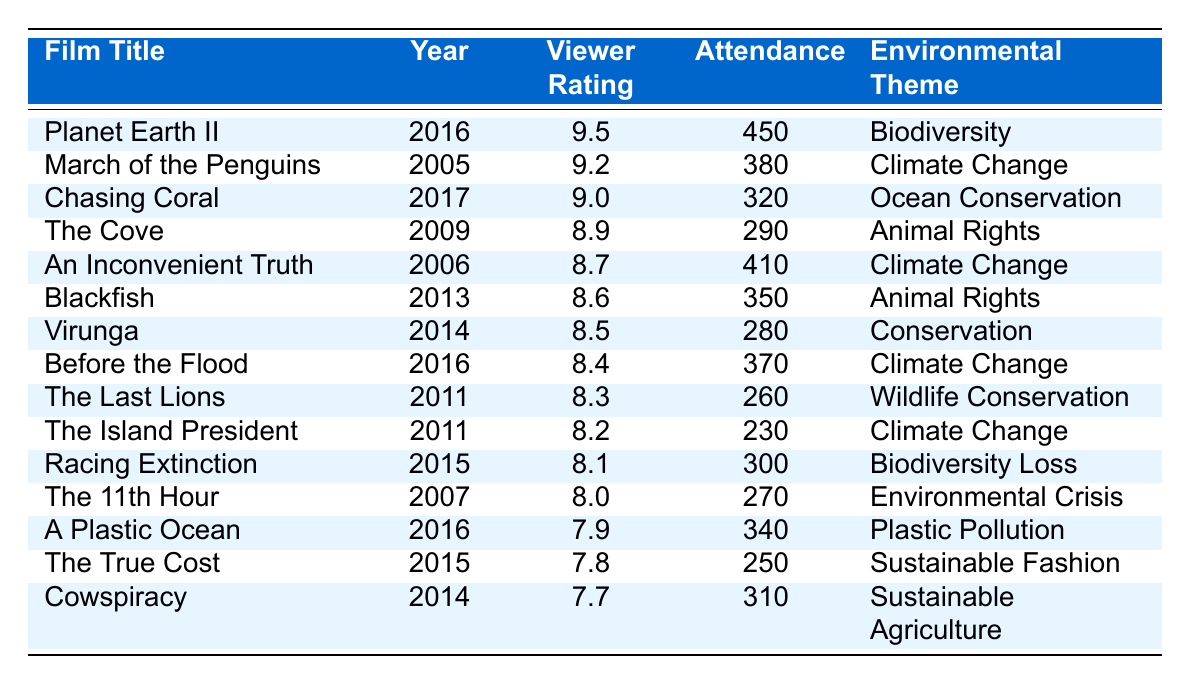What is the highest viewer rating among the films? The table shows that the highest viewer rating is 9.5 for the film "Planet Earth II."
Answer: 9.5 Which film had the lowest attendance? Reviewing the table, "The Island President" had the lowest attendance with 230 viewers.
Answer: 230 How many films focused on Climate Change? By counting the entries with "Climate Change" as the environmental theme, we find there are 4 films: "March of the Penguins," "An Inconvenient Truth," "Before the Flood," and "The Island President."
Answer: 4 What is the average viewer rating of the films focusing on Animal Rights? The films "The Cove" (8.9) and "Blackfish" (8.6) are the only two in this category. Their average is calculated as (8.9 + 8.6) / 2 = 8.75.
Answer: 8.75 Which environmental theme has the highest average viewer rating? To find this, we sum the viewer ratings for each theme: Biodiversity (9.5 + 8.1), Climate Change (9.2 + 8.7 + 8.4 + 8.2), Ocean Conservation (9.0), Animal Rights (8.9 + 8.6), Conservation (8.5), and the other themes. After calculating the averages, we see that Biodiversity has the highest average rating at (9.5 + 8.1) / 2 = 8.8.
Answer: Biodiversity Which film had an attendance of over 400 viewers? Scanning the table reveals that "Planet Earth II" had attendance over 400, specifically 450 viewers.
Answer: "Planet Earth II" Which film is the most recent and what is its viewer rating? The most recent film is "Chasing Coral," released in 2017, and it has a viewer rating of 9.0.
Answer: "Chasing Coral; 9.0" What is the difference in viewer ratings between the highest-rated and lowest-rated film? The highest-rated film is "Planet Earth II" with a rating of 9.5, and the lowest is "Cowspiracy" with 7.7. The difference is 9.5 - 7.7 = 1.8.
Answer: 1.8 How many films were released after 2015? The films released after 2015 are "Chasing Coral" (2017), "Before the Flood" (2016), and "A Plastic Ocean" (2016), totaling 3 films.
Answer: 3 Is there a film focusing on Sustainable Fashion in this list? Yes, "The True Cost" is listed as a film focusing on Sustainable Fashion.
Answer: Yes 